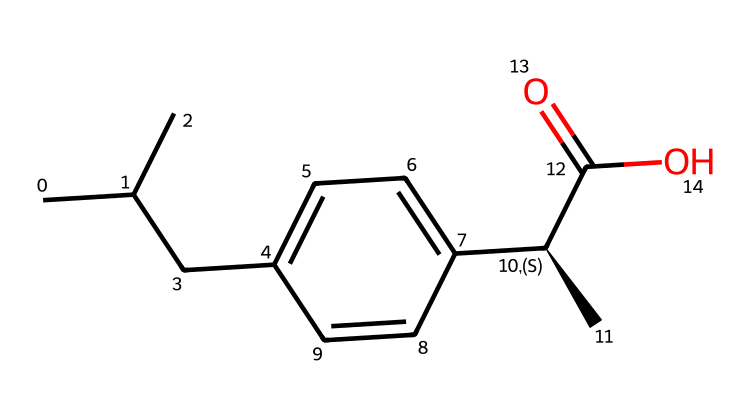What is the systematic name of this chemical? The SMILES representation indicates that the compound has a carboxylic acid functional group (C(=O)O) and specific carbon chain and aromatic structure. By deciphering these features, it can be identified as 2-(4-isobutylphenyl)propanoic acid, commonly known as ibuprofen.
Answer: ibuprofen How many carbon atoms are present in the molecule? By analyzing the SMILES, we can count the "C" symbols to identify the total number of carbon atoms. There are 13 carbon atoms in the structure.
Answer: 13 What functional group is present in this molecule? In the SMILES, the part "C(=O)O" indicates a carbon atom double-bonded to an oxygen atom and single-bonded to a hydroxyl group. This identifies the presence of a carboxylic acid functional group.
Answer: carboxylic acid How many chiral centers are there in the molecule? The "C@H" notation in the SMILES denotes that there is one chiral center in this molecule, indicating asymmetry and hence the possibility for stereoisomerism.
Answer: 1 Does this molecule contain any aromatic rings? In the SMILES, the notation "c" signifies that the molecule includes aromatic carbon atoms, which indicates the presence of an aromatic ring in the structure.
Answer: yes What type of isomerism can ibuprofen exhibit due to its chiral center? The presence of the chiral center allows ibuprofen to exist in different stereoisomers, specifically enantiomers, which are molecules that are non-superimposable mirror images of each other.
Answer: enantiomerism 